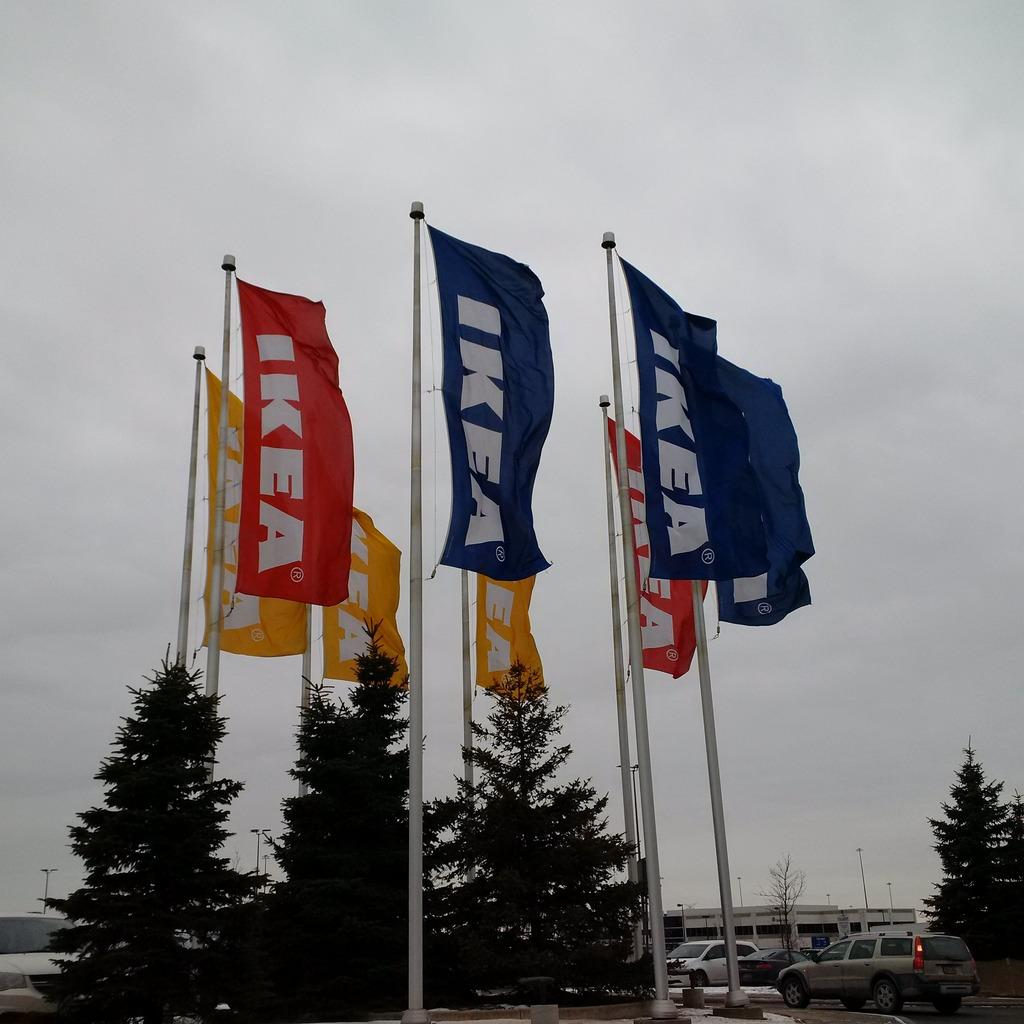What type of objects can be seen in the image that are white in color? There are white-colored poles in the image. What is attached to the poles? Flags are attached to the poles. What type of natural elements can be seen in the image? There are trees in the image. What type of man-made structures can be seen on the road in the image? There are cars on the road in the image. What can be seen in the background of the image? There is a building and the sky visible in the background of the image. What type of land is visible in the image? There is no specific type of land mentioned or visible in the image. What type of cart is being used to transport the flags in the image? There is no cart present in the image; flags are attached to the poles. 